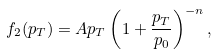<formula> <loc_0><loc_0><loc_500><loc_500>f _ { 2 } ( p _ { T } ) = A p _ { T } \left ( 1 + \frac { p _ { T } } { p _ { 0 } } \right ) ^ { - n } ,</formula> 